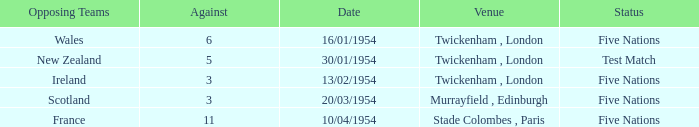In the stade colombes, paris venue, what is the least amount of games played? 11.0. 